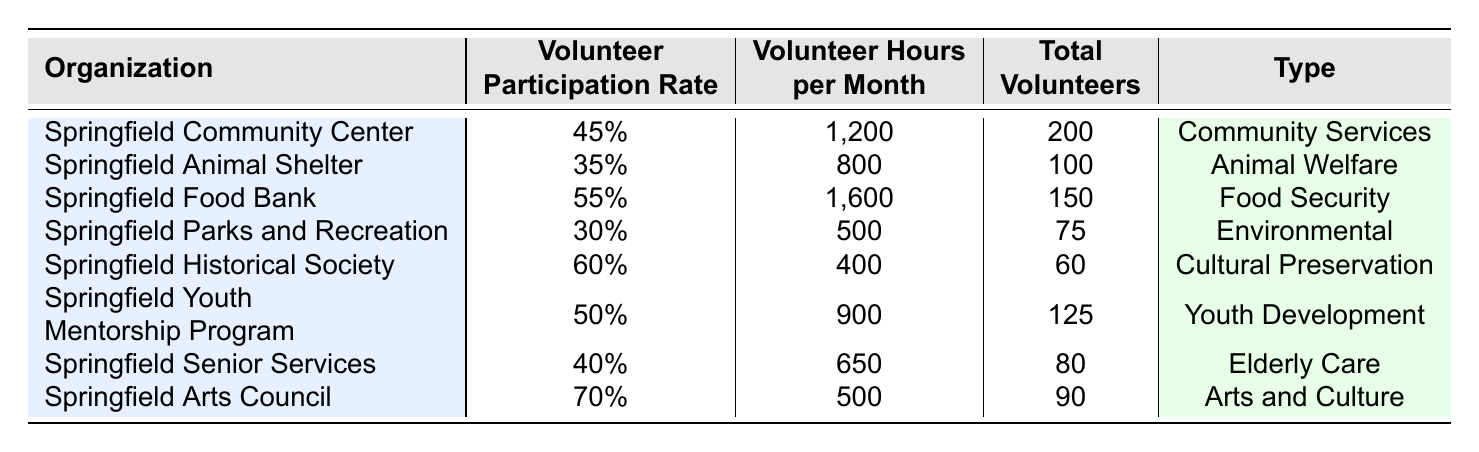What is the volunteer participation rate for the Springfield Arts Council? The table shows that the volunteer participation rate for the Springfield Arts Council is listed as 70%.
Answer: 70% Which organization has the highest volunteer hours per month? By comparing the 'Volunteer Hours per Month' column, Springfield Food Bank has the highest value at 1600 hours.
Answer: Springfield Food Bank How many total volunteers are there in the Springfield Historical Society? The table indicates that the total number of volunteers for the Springfield Historical Society is 60.
Answer: 60 What is the average volunteer participation rate across all organizations? To find the average, sum participation rates (0.45 + 0.35 + 0.55 + 0.30 + 0.60 + 0.50 + 0.40 + 0.70 = 3.65) and divide by 8 (3.65/8 = 0.45625), resulting in an average of approximately 45.63%.
Answer: 45.63% Is the volunteer participation rate for the Springfield Animal Shelter higher than that of Springfield Senior Services? Comparing the rates, Springfield Animal Shelter's rate is 35%, while Springfield Senior Services has a rate of 40%. Therefore, it is not higher.
Answer: No Which type of organization has the lowest volunteer participation rate? Reviewing the 'Volunteer Participation Rate' column, Springfield Parks and Recreation has the lowest rate at 30%.
Answer: Springfield Parks and Recreation What is the total number of volunteers serving in community services organizations? The organizations that fall under community services are Springfield Community Center (200 volunteers) and Springfield Senior Services (80 volunteers). Adding these gives 200 + 80 = 280.
Answer: 280 If you combine the volunteer hours per month for the Springfield Food Bank and Springfield Youth Mentorship Program, what is the total? The Springfield Food Bank has 1600 hours and the Youth Mentorship Program has 900 hours. Adding these totals: 1600 + 900 = 2500 hours.
Answer: 2500 hours What proportion of the total volunteers are found in the Springfield Community Center? The total number of volunteers summed across all organizations is (200 + 100 + 150 + 75 + 60 + 125 + 80 + 90 = 880). The proportion for the Community Center is 200/880, which simplifies to approximately 0.227.
Answer: 22.7% Does the Springfield Historical Society have more volunteers than the Springfield Animal Shelter? Springfield Historical Society has 60 volunteers while the Animal Shelter has 100. Since 60 is less than 100, the statement is false.
Answer: No 